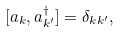<formula> <loc_0><loc_0><loc_500><loc_500>[ a _ { k } , a ^ { \dagger } _ { k ^ { \prime } } ] = \delta _ { k k ^ { \prime } } ,</formula> 